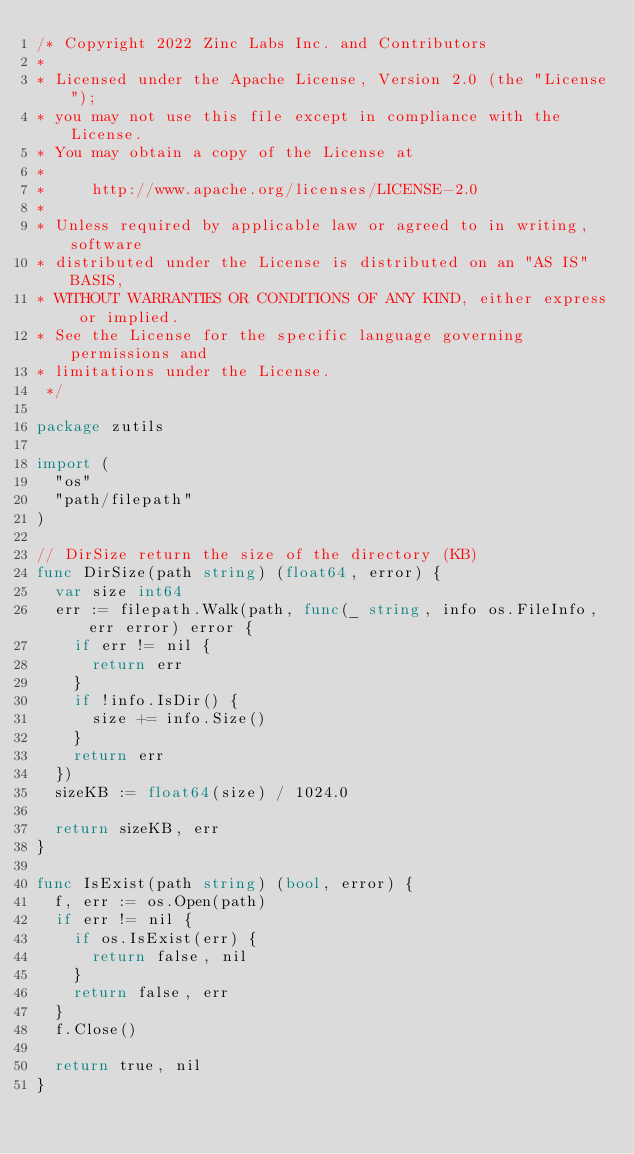Convert code to text. <code><loc_0><loc_0><loc_500><loc_500><_Go_>/* Copyright 2022 Zinc Labs Inc. and Contributors
*
* Licensed under the Apache License, Version 2.0 (the "License");
* you may not use this file except in compliance with the License.
* You may obtain a copy of the License at
*
*     http://www.apache.org/licenses/LICENSE-2.0
*
* Unless required by applicable law or agreed to in writing, software
* distributed under the License is distributed on an "AS IS" BASIS,
* WITHOUT WARRANTIES OR CONDITIONS OF ANY KIND, either express or implied.
* See the License for the specific language governing permissions and
* limitations under the License.
 */

package zutils

import (
	"os"
	"path/filepath"
)

// DirSize return the size of the directory (KB)
func DirSize(path string) (float64, error) {
	var size int64
	err := filepath.Walk(path, func(_ string, info os.FileInfo, err error) error {
		if err != nil {
			return err
		}
		if !info.IsDir() {
			size += info.Size()
		}
		return err
	})
	sizeKB := float64(size) / 1024.0

	return sizeKB, err
}

func IsExist(path string) (bool, error) {
	f, err := os.Open(path)
	if err != nil {
		if os.IsExist(err) {
			return false, nil
		}
		return false, err
	}
	f.Close()

	return true, nil
}
</code> 